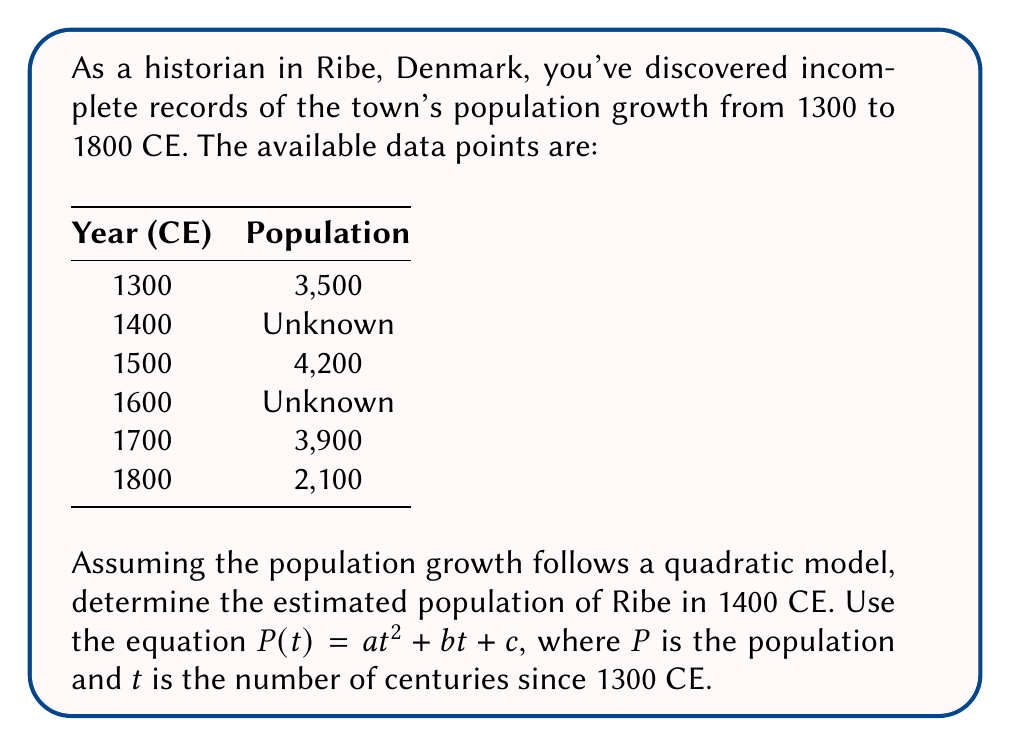Show me your answer to this math problem. Let's approach this step-by-step:

1) We have three known data points:
   $(0, 3500)$, $(2, 4200)$, $(4, 3900)$, $(5, 2100)$

2) We need to find $a$, $b$, and $c$ in the equation $P(t) = at^2 + bt + c$

3) Substituting our known points:
   $3500 = a(0)^2 + b(0) + c$
   $4200 = a(2)^2 + b(2) + c$
   $3900 = a(4)^2 + b(4) + c$
   $2100 = a(5)^2 + b(5) + c$

4) From the first equation: $c = 3500$

5) Subtracting the first equation from the others:
   $700 = 4a + 2b$
   $400 = 16a + 4b$
   $-1400 = 25a + 5b$

6) From the second and third equations:
   $300 = 12a + 2b$
   $150 = 6a + b$
   $b = 150 - 6a$

7) Substituting this into the fourth equation:
   $-1400 = 25a + 5(150 - 6a)$
   $-1400 = 25a + 750 - 30a$
   $-2150 = -5a$
   $a = 430$

8) Now we can find $b$:
   $b = 150 - 6(430) = -2430$

9) Our quadratic equation is:
   $P(t) = 430t^2 - 2430t + 3500$

10) To find the population in 1400 CE, we substitute $t = 1$:
    $P(1) = 430(1)^2 - 2430(1) + 3500 = 1500$

Therefore, the estimated population of Ribe in 1400 CE was 1,500.
Answer: 1,500 